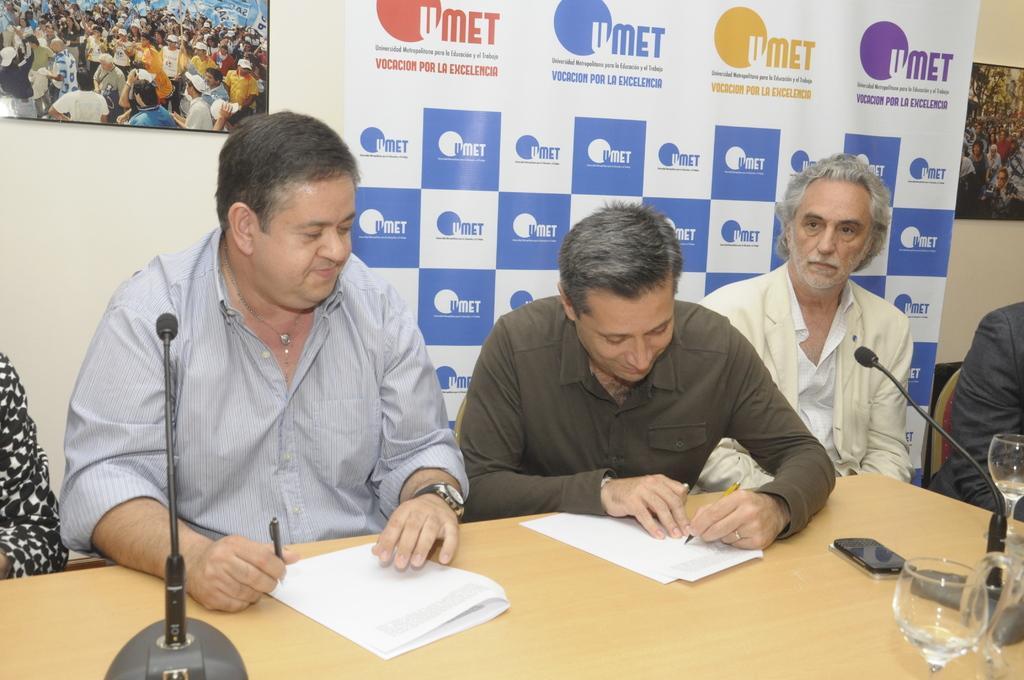Describe this image in one or two sentences. In this image there are five persons sitting on the chairs, in which two of them are holding pens, there are mike's, glasses, papers and a mobile on the table, and in the background there are frames attached to the wall, banner. 